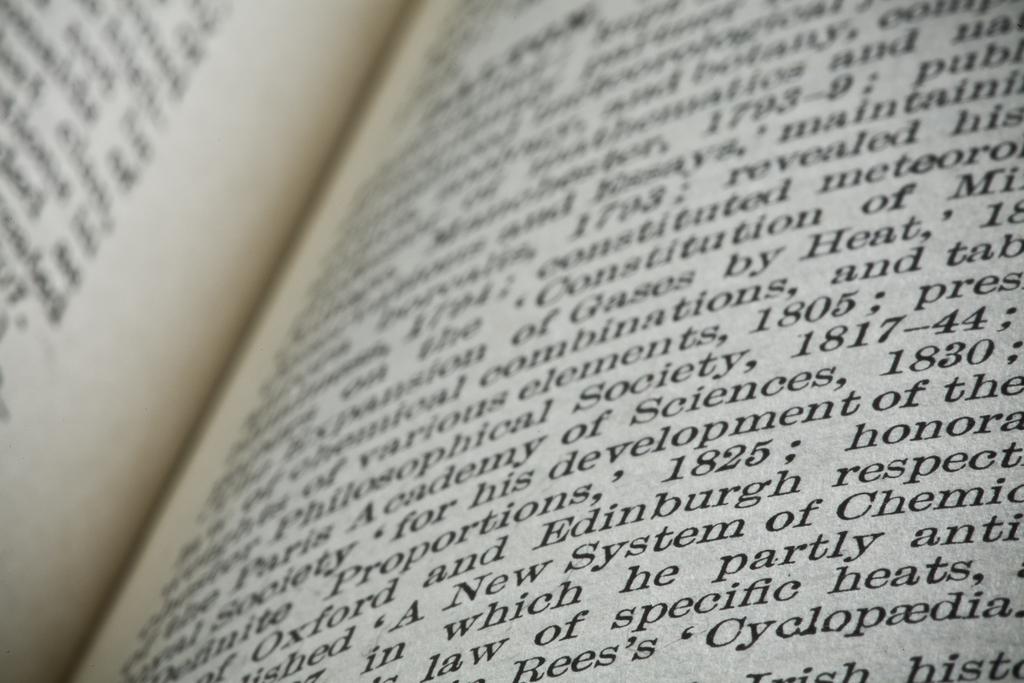Is this a college level chemistry book?
Your answer should be compact. Unanswerable. What is a year mentioned on this page?
Your response must be concise. 1825. 